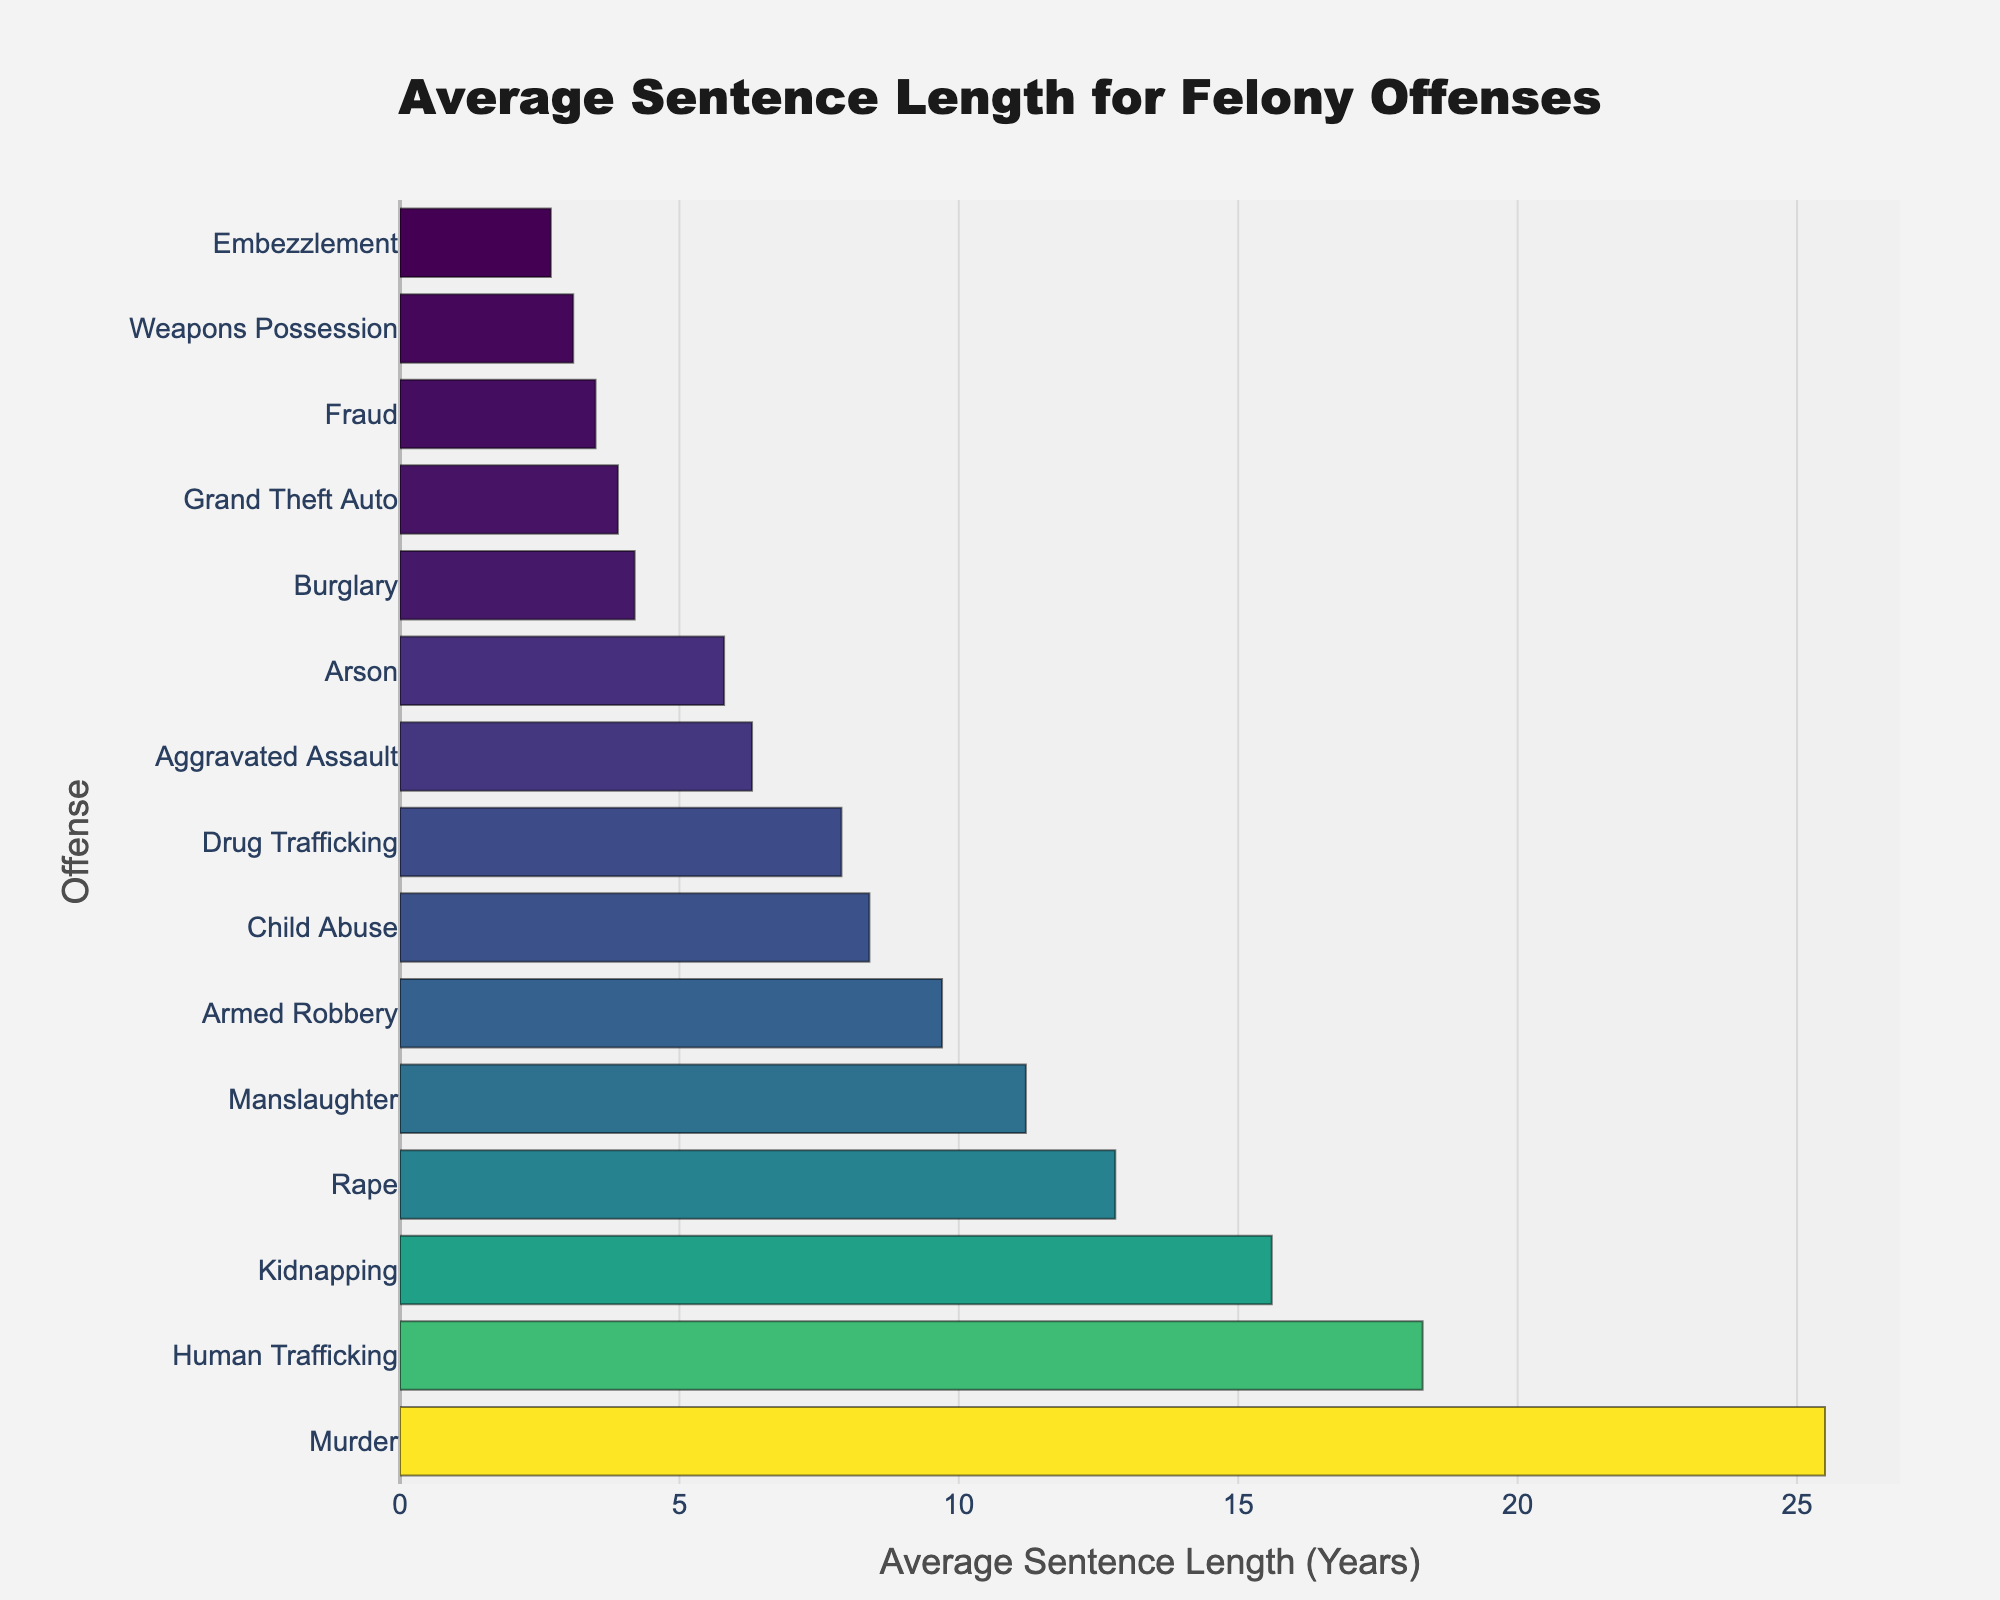What are the top three offenses with the longest average sentence lengths? To find the top three offenses with the longest average sentence lengths, we look for the first three bars in the chart, sorted in descending order of sentence length. These are "Murder" with 25.5 years, "Human Trafficking" with 18.3 years, and "Kidnapping" with 15.6 years.
Answer: Murder, Human Trafficking, Kidnapping What is the difference in average sentence length between Murder and Manslaughter? First, identify the average sentence lengths for both offenses: Murder has 25.5 years, and Manslaughter has 11.2 years. Subtract Manslaughter from Murder: 25.5 - 11.2 = 14.3 years.
Answer: 14.3 years Which offense has a shorter average sentence, Burglary or Arson, and by how much? Identify the average sentence lengths: Burglary has 4.2 years, and Arson has 5.8 years. Subtract Burglary's sentence from Arson’s: 5.8 - 4.2 = 1.6 years. Burglary is shorter.
Answer: Burglary by 1.6 years How many offenses have an average sentence length greater than 10 years? Count the number of bars representing offenses with an average sentence length greater than 10 years. These are "Murder", "Human Trafficking", "Kidnapping", "Rape", and "Manslaughter". That's 5 offenses.
Answer: 5 Is the average sentence length for Drug Trafficking greater than that of Child Abuse? Compare the average sentence lengths: Drug Trafficking has 7.9 years, while Child Abuse has 8.4 years. Drug Trafficking's sentence length is less.
Answer: No What is the median average sentence length across all the offenses listed? To find the median, list all sentence lengths in ascending order: 2.7, 3.1, 3.5, 3.9, 4.2, 5.8, 6.3, 7.9, 8.4, 9.7, 11.2, 12.8, 15.6, 18.3, 25.5. The middle value (8th position in ordered list) is 7.9 years.
Answer: 7.9 years Compared to the average sentence length for Rape, how much shorter is the average sentence for Aggravated Assault? Identify the average sentence lengths: Rape has 12.8 years, and Aggravated Assault has 6.3 years. Subtract Aggravated Assault's sentence from Rape’s: 12.8 - 6.3 = 6.5 years.
Answer: 6.5 years What's the total combined average sentence length for Burglary, Fraud, and Embezzlement? Identify the average sentence lengths for each: Burglary is 4.2 years, Fraud is 3.5 years, and Embezzlement is 2.7 years. Add them together: 4.2 + 3.5 + 2.7 = 10.4 years.
Answer: 10.4 years What is the length difference between the shortest and longest average sentences in the figure? The shortest average sentence length is for Embezzlement (2.7 years), and the longest is for Murder (25.5 years). Subtract Embezzlement's sentence from Murder’s: 25.5 - 2.7 = 22.8 years.
Answer: 22.8 years 